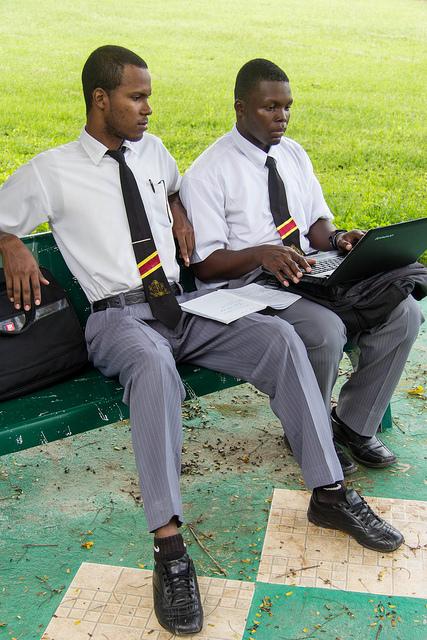Are they wearing uniforms?
Give a very brief answer. Yes. How many people are there?
Write a very short answer. 2. What brand of socks is the man on the left wearing?
Give a very brief answer. Nike. 